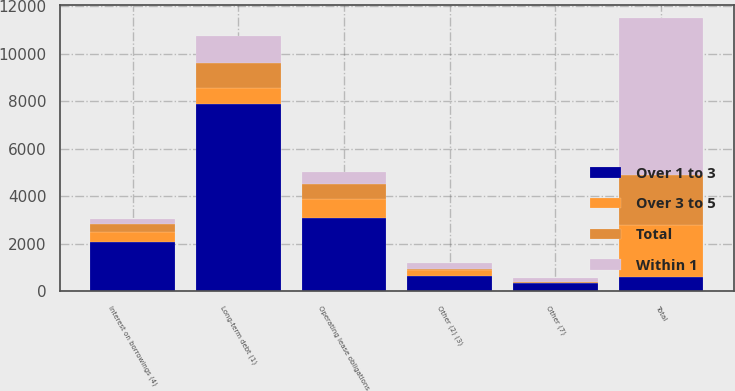<chart> <loc_0><loc_0><loc_500><loc_500><stacked_bar_chart><ecel><fcel>Long-term debt (1)<fcel>Other (2) (3)<fcel>Interest on borrowings (4)<fcel>Operating lease obligations<fcel>Other (7)<fcel>Total<nl><fcel>Over 1 to 3<fcel>7880<fcel>666<fcel>2090<fcel>3072<fcel>338<fcel>610<nl><fcel>Within 1<fcel>1129<fcel>230<fcel>223<fcel>502<fcel>178<fcel>6618<nl><fcel>Over 3 to 5<fcel>690<fcel>229<fcel>396<fcel>826<fcel>25<fcel>2175<nl><fcel>Total<fcel>1037<fcel>62<fcel>355<fcel>610<fcel>28<fcel>2096<nl></chart> 